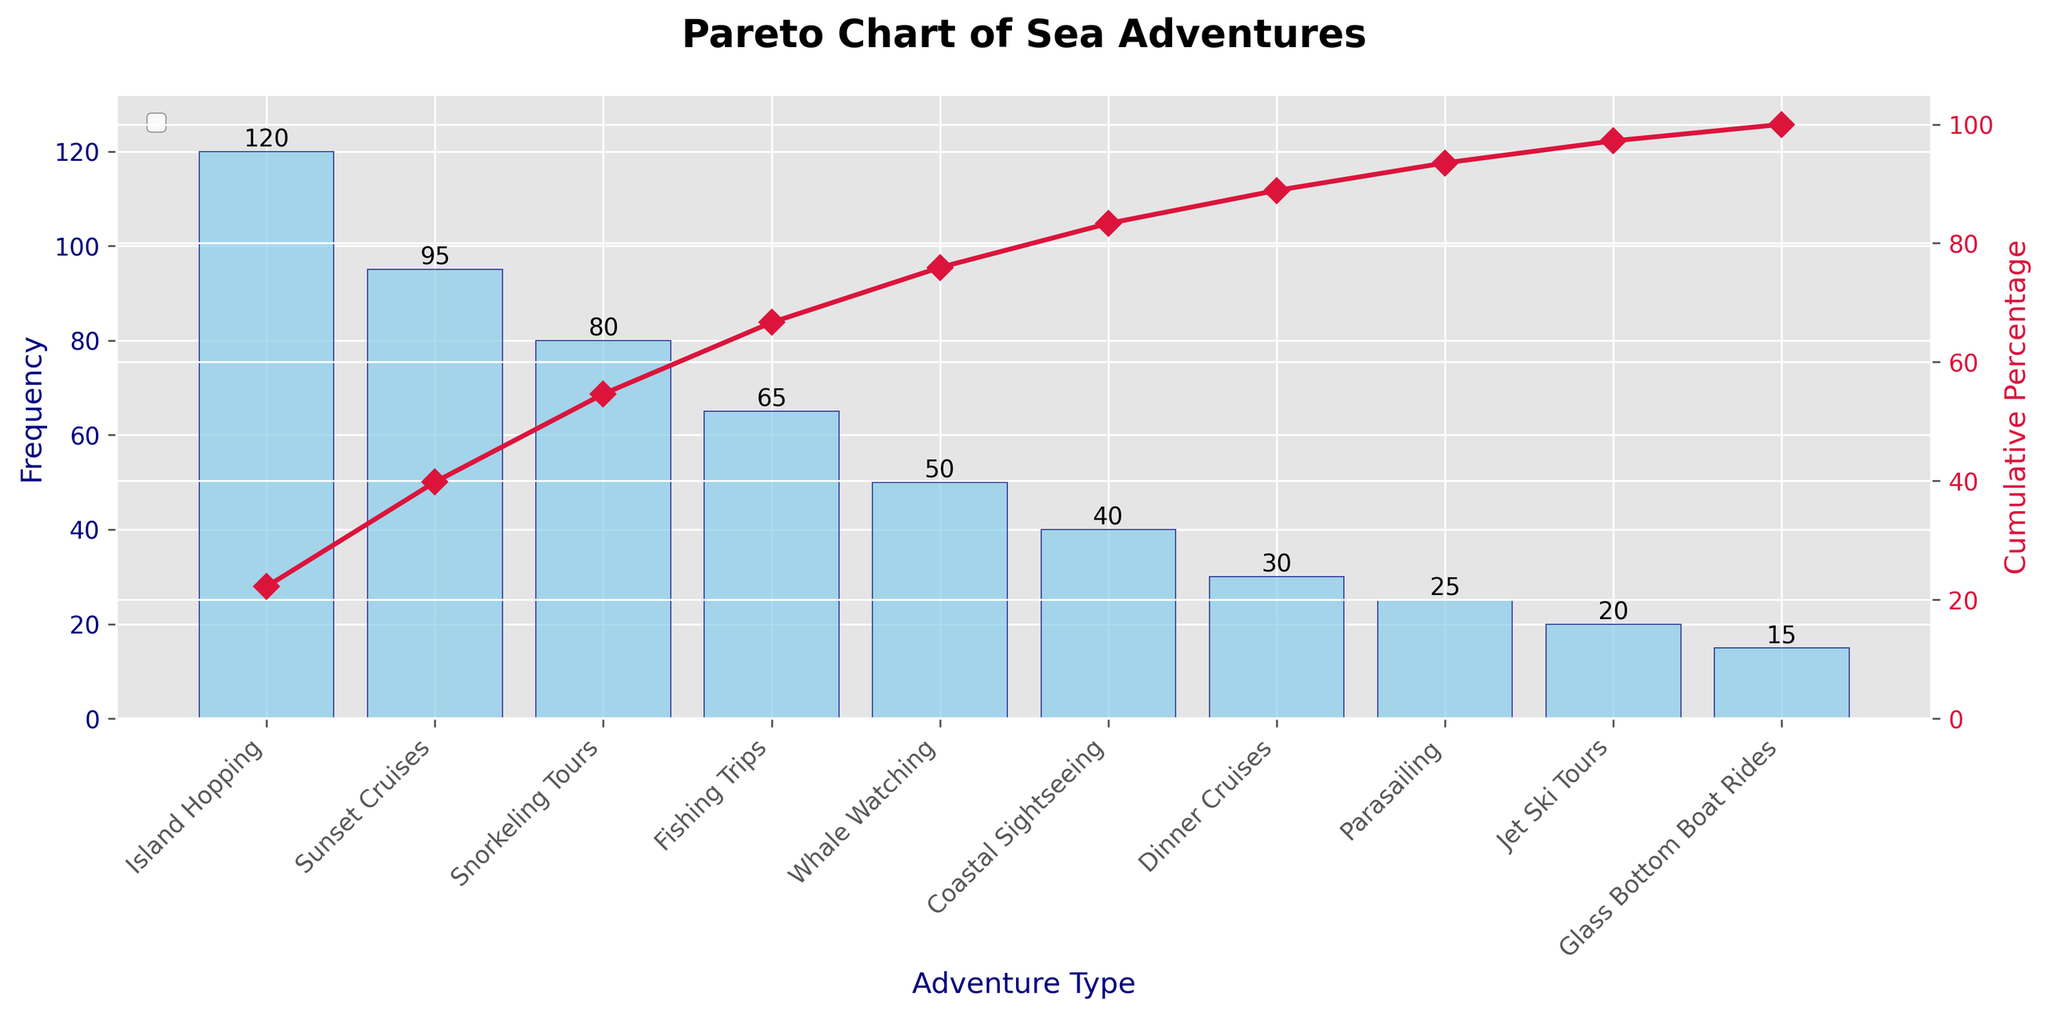What is the most popular sea adventure? The most popular sea adventure can be identified by looking at the highest bar in the chart. The bar for "Island Hopping" is the tallest, indicating it has the highest frequency of 120.
Answer: Island Hopping Which sea adventure has the least frequency? The least frequent sea adventure is shown by the shortest bar in the chart. The bar for "Glass Bottom Boat Rides" is the shortest, with a frequency of 15.
Answer: Glass Bottom Boat Rides What is the cumulative percentage after "Snorkeling Tours"? The cumulative percentage can be calculated by summing the individual frequencies up to "Snorkeling Tours" and then finding the percentage. Frequencies up to "Snorkeling Tours" are 120 (Island Hopping) + 95 (Sunset Cruises) + 80 (Snorkeling Tours) = 295. The total sum of all frequencies is 540. The cumulative percentage is (295/540)*100 ≈ 54.63%.
Answer: Approximately 54.63% How many sea adventures are listed in the chart? The number of sea adventures listed can be counted by the number of bars in the chart. There are 10 bars, each representing a different sea adventure.
Answer: 10 What is the frequency difference between "Whale Watching" and "Fishing Trips"? The frequencies for "Fishing Trips" and "Whale Watching" are 65 and 50, respectively. The difference is 65 - 50 = 15.
Answer: 15 Which two sea adventures combined have a frequency closest to "Sunset Cruises"? The frequency of "Sunset Cruises" is 95. The combination of two adventures need to sum closest to 95. "Snorkeling Tours" (80) and "Glass Bottom Boat Rides" (15) together make 80 + 15 = 95, which is exactly 95.
Answer: Snorkeling Tours and Glass Bottom Boat Rides At what cumulative percentage does "Jet Ski Tours" occur? The cumulative percentages need to be calculated by summing the frequencies up to "Jet Ski Tours". Frequencies up to "Jet Ski Tours" are 470 (sum of previous frequencies) + 20 = 490. The cumulative percentage for 490 out of total 540 is (490/540)*100 ≈ 90.74%.
Answer: Approximately 90.74% By what percentage does "Parasailing" (25) occur before reaching 85% cumulative percentage? From the cumulative percentage calculations, "Parasailing" occurs just before the cumulative percentage reaches 85%. Adding the cumulative frequencies up to "Dinner Cruises" gives 95 + 80 + 65 + 50 + 40 + 30 = 360 and the percentage is 360/540 ≈ 66.67%, hence before reaching 85%. The remaining steps show that "Parasailing"'s cumulative percentage is 385/540 ≈ 71.30%.
Answer: 71.30% 